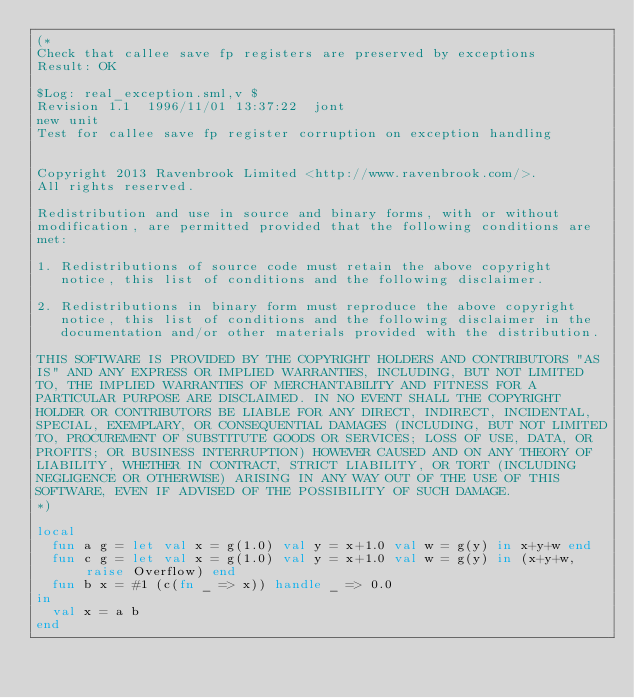<code> <loc_0><loc_0><loc_500><loc_500><_SML_>(*
Check that callee save fp registers are preserved by exceptions
Result: OK
 
$Log: real_exception.sml,v $
Revision 1.1  1996/11/01 13:37:22  jont
new unit
Test for callee save fp register corruption on exception handling


Copyright 2013 Ravenbrook Limited <http://www.ravenbrook.com/>.
All rights reserved.

Redistribution and use in source and binary forms, with or without
modification, are permitted provided that the following conditions are
met:

1. Redistributions of source code must retain the above copyright
   notice, this list of conditions and the following disclaimer.

2. Redistributions in binary form must reproduce the above copyright
   notice, this list of conditions and the following disclaimer in the
   documentation and/or other materials provided with the distribution.

THIS SOFTWARE IS PROVIDED BY THE COPYRIGHT HOLDERS AND CONTRIBUTORS "AS
IS" AND ANY EXPRESS OR IMPLIED WARRANTIES, INCLUDING, BUT NOT LIMITED
TO, THE IMPLIED WARRANTIES OF MERCHANTABILITY AND FITNESS FOR A
PARTICULAR PURPOSE ARE DISCLAIMED. IN NO EVENT SHALL THE COPYRIGHT
HOLDER OR CONTRIBUTORS BE LIABLE FOR ANY DIRECT, INDIRECT, INCIDENTAL,
SPECIAL, EXEMPLARY, OR CONSEQUENTIAL DAMAGES (INCLUDING, BUT NOT LIMITED
TO, PROCUREMENT OF SUBSTITUTE GOODS OR SERVICES; LOSS OF USE, DATA, OR
PROFITS; OR BUSINESS INTERRUPTION) HOWEVER CAUSED AND ON ANY THEORY OF
LIABILITY, WHETHER IN CONTRACT, STRICT LIABILITY, OR TORT (INCLUDING
NEGLIGENCE OR OTHERWISE) ARISING IN ANY WAY OUT OF THE USE OF THIS
SOFTWARE, EVEN IF ADVISED OF THE POSSIBILITY OF SUCH DAMAGE.
*)

local
  fun a g = let val x = g(1.0) val y = x+1.0 val w = g(y) in x+y+w end
  fun c g = let val x = g(1.0) val y = x+1.0 val w = g(y) in (x+y+w, raise Overflow) end
  fun b x = #1 (c(fn _ => x)) handle _ => 0.0
in
  val x = a b
end
</code> 